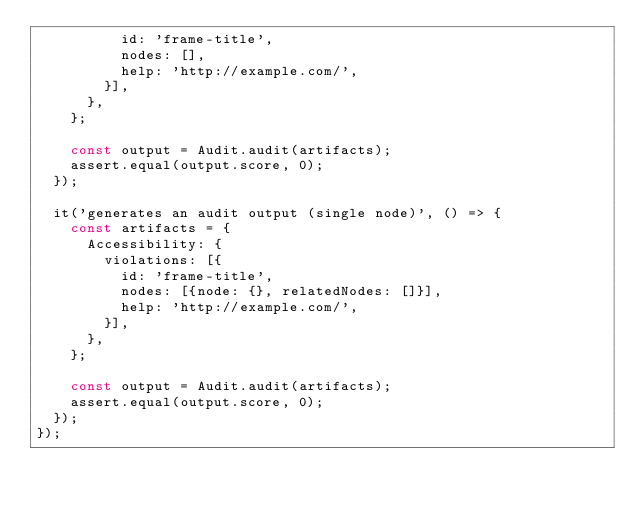Convert code to text. <code><loc_0><loc_0><loc_500><loc_500><_JavaScript_>          id: 'frame-title',
          nodes: [],
          help: 'http://example.com/',
        }],
      },
    };

    const output = Audit.audit(artifacts);
    assert.equal(output.score, 0);
  });

  it('generates an audit output (single node)', () => {
    const artifacts = {
      Accessibility: {
        violations: [{
          id: 'frame-title',
          nodes: [{node: {}, relatedNodes: []}],
          help: 'http://example.com/',
        }],
      },
    };

    const output = Audit.audit(artifacts);
    assert.equal(output.score, 0);
  });
});
</code> 